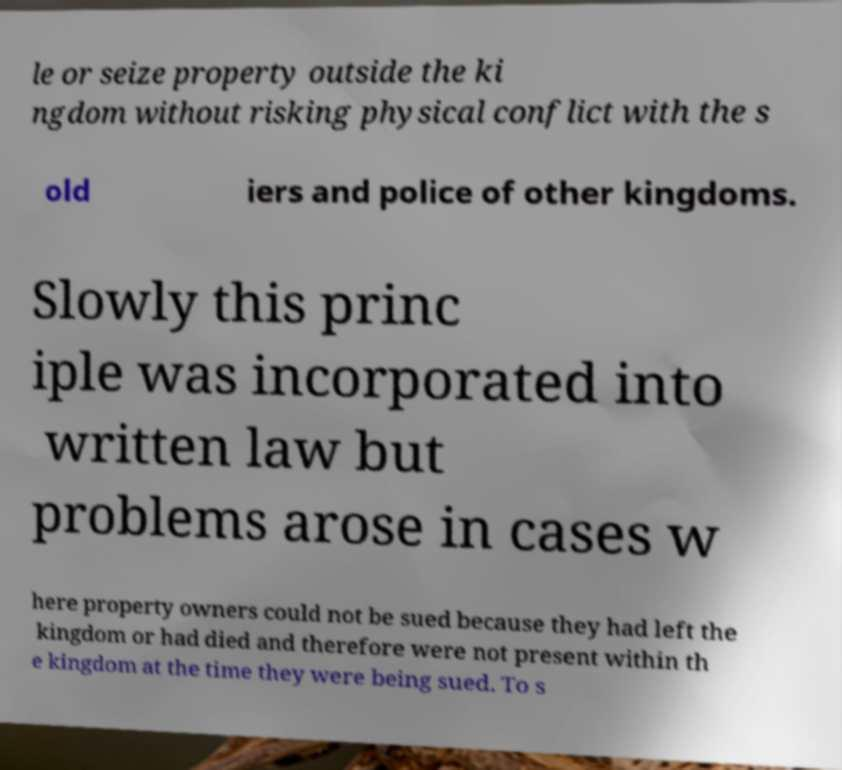Could you extract and type out the text from this image? le or seize property outside the ki ngdom without risking physical conflict with the s old iers and police of other kingdoms. Slowly this princ iple was incorporated into written law but problems arose in cases w here property owners could not be sued because they had left the kingdom or had died and therefore were not present within th e kingdom at the time they were being sued. To s 